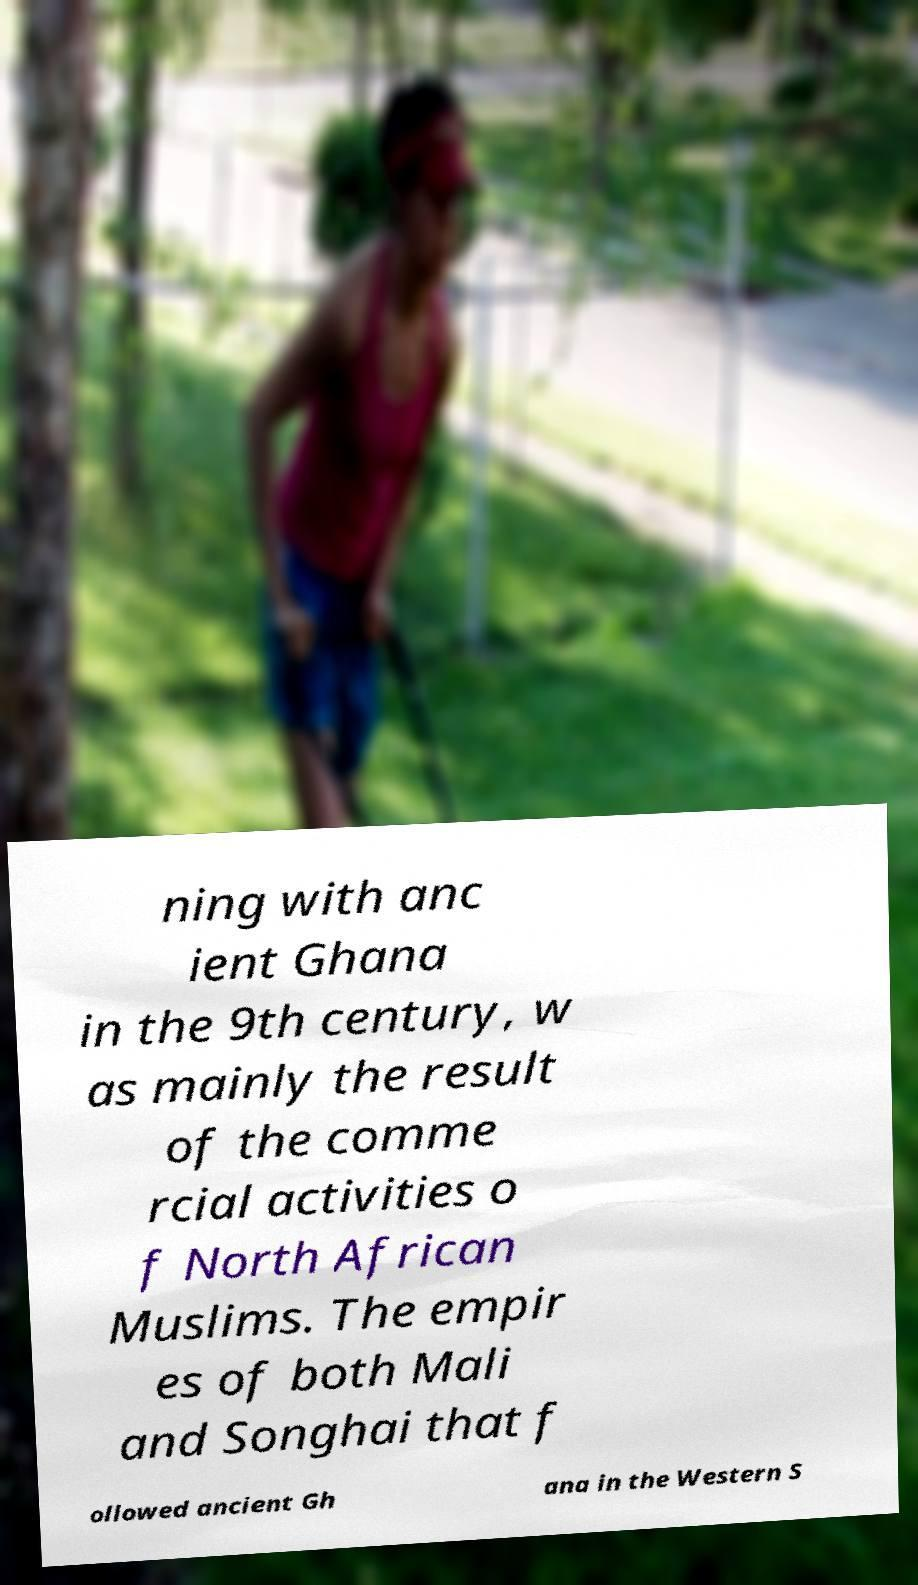What messages or text are displayed in this image? I need them in a readable, typed format. ning with anc ient Ghana in the 9th century, w as mainly the result of the comme rcial activities o f North African Muslims. The empir es of both Mali and Songhai that f ollowed ancient Gh ana in the Western S 